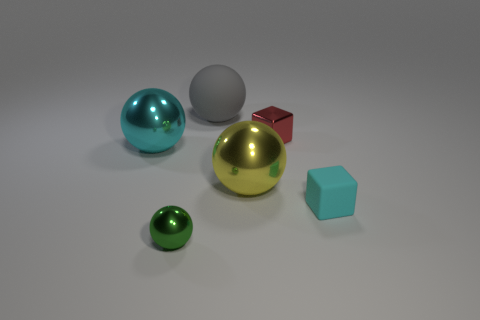Subtract all big cyan balls. How many balls are left? 3 Add 3 small purple metal cylinders. How many objects exist? 9 Subtract all cyan spheres. How many spheres are left? 3 Subtract all spheres. How many objects are left? 2 Subtract 3 spheres. How many spheres are left? 1 Subtract all gray balls. Subtract all yellow cylinders. How many balls are left? 3 Add 3 big metal spheres. How many big metal spheres exist? 5 Subtract 0 green cylinders. How many objects are left? 6 Subtract all purple rubber objects. Subtract all big gray rubber things. How many objects are left? 5 Add 5 tiny metal spheres. How many tiny metal spheres are left? 6 